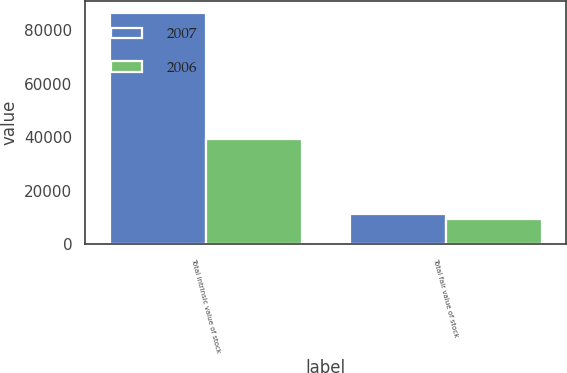<chart> <loc_0><loc_0><loc_500><loc_500><stacked_bar_chart><ecel><fcel>Total intrinsic value of stock<fcel>Total fair value of stock<nl><fcel>2007<fcel>86530<fcel>11151<nl><fcel>2006<fcel>39471<fcel>9573<nl></chart> 